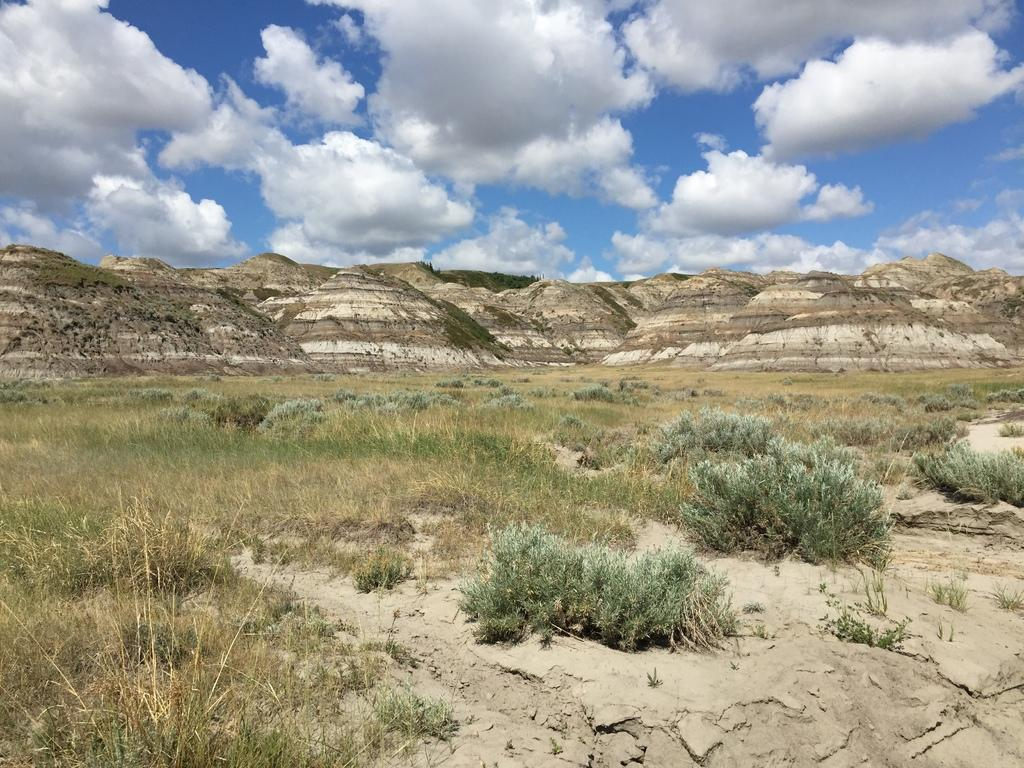What type of surface is visible in the image? There is grass on the surface in the image. What other natural elements can be seen in the image? There are plants in the image. What can be seen in the distance in the image? There are mountains in the background of the image. What else is visible in the background of the image? There are trees and the sky in the background of the image. Can you see any fairies flying around the plants in the image? There are no fairies present in the image; it features grass, plants, mountains, trees, and the sky. What type of cloth is draped over the mountains in the image? There is no cloth draped over the mountains in the image; it is a natural landscape with no man-made elements. 